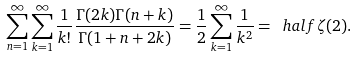Convert formula to latex. <formula><loc_0><loc_0><loc_500><loc_500>\sum _ { n = 1 } ^ { \infty } \sum _ { k = 1 } ^ { \infty } \frac { 1 } { k ! } \frac { \Gamma ( 2 k ) \Gamma ( n + k ) } { \Gamma ( 1 + n + 2 k ) } = \frac { 1 } { 2 } \sum _ { k = 1 } ^ { \infty } \frac { 1 } { k ^ { 2 } } = \ h a l f \zeta ( 2 ) .</formula> 